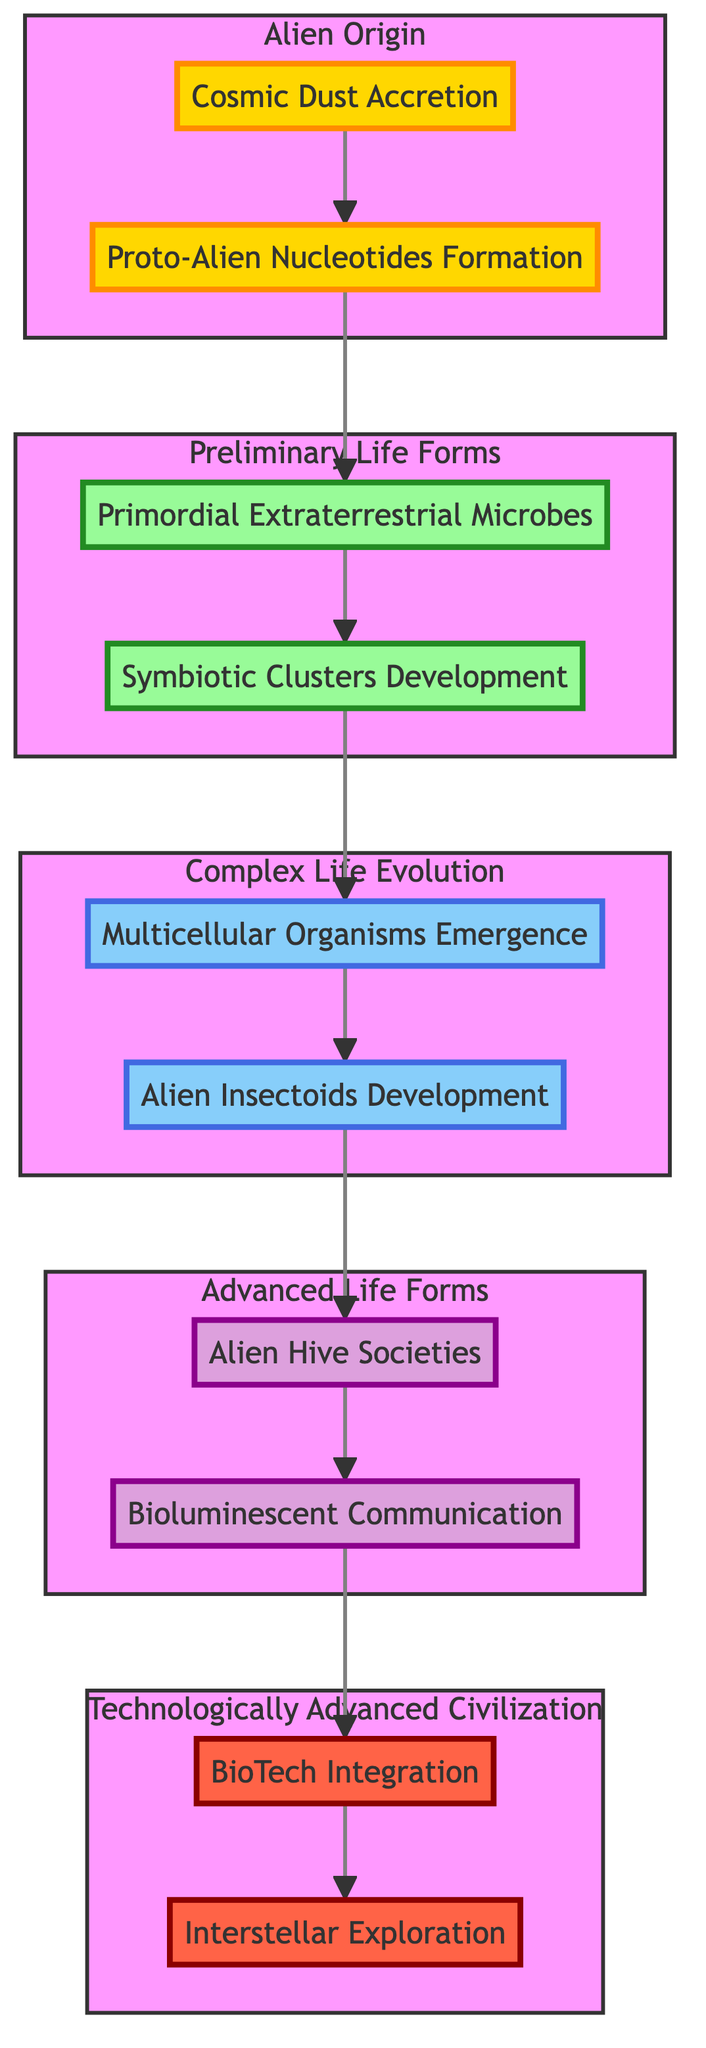What are the two elements in the Alien Origin stage? The Alien Origin stage includes "Cosmic Dust Accretion" and "Proto-Alien Nucleotides Formation." These are the foundational processes leading to the emergence of the alien species.
Answer: Cosmic Dust Accretion, Proto-Alien Nucleotides Formation How many nodes are present in the diagram? By counting all unique stages and elements, we find there are a total of 10 nodes: 5 primary stages and 5 elements.
Answer: 10 What is the relationship between Multicellular Organisms Emergence and Alien Insectoids Development? These two elements are part of the "Complex Life Evolution" stage, indicating they are sequential steps in the progression of life complexity within the evolutionary process.
Answer: Sequential What is the final stage of the alien species evolution depicted in the diagram? The diagram outlines "Technologically Advanced Civilization" as the final stage, representing the apex of development for the alien species.
Answer: Technologically Advanced Civilization How many distinct life forms are indicated in the Advanced Life Forms stage? The Advanced Life Forms stage comprises two distinct life forms: "Alien Hive Societies" and "Bioluminescent Communication," reflecting advances in social structure and communication.
Answer: 2 What element follows Symbiotic Clusters Development in the evolutionary process? The diagram indicates that "Symbiotic Clusters Development" is followed by "Multicellular Organisms Emergence," showing a logical progression from basic life forms to more complex ones.
Answer: Multicellular Organisms Emergence Which element is directly linked to BioTech Integration in the flow? According to the diagram, "BioTech Integration" is directly linked to "Interstellar Exploration," indicating that advancements in biotechnology directly facilitate the exploration of space.
Answer: Interstellar Exploration What type of society develops in the Advanced Life Forms stage? This stage is characterized by the development of "Alien Hive Societies," signifying a complex and organized societal structure among the alien species.
Answer: Alien Hive Societies How does the diagram show the flow of evolution among alien species? The diagram illustrates a clear bottom-to-up flow, where each stage builds on the previous one, demonstrating the cumulative nature of evolutionary processes from origin to advanced civilization.
Answer: Cumulative flow 